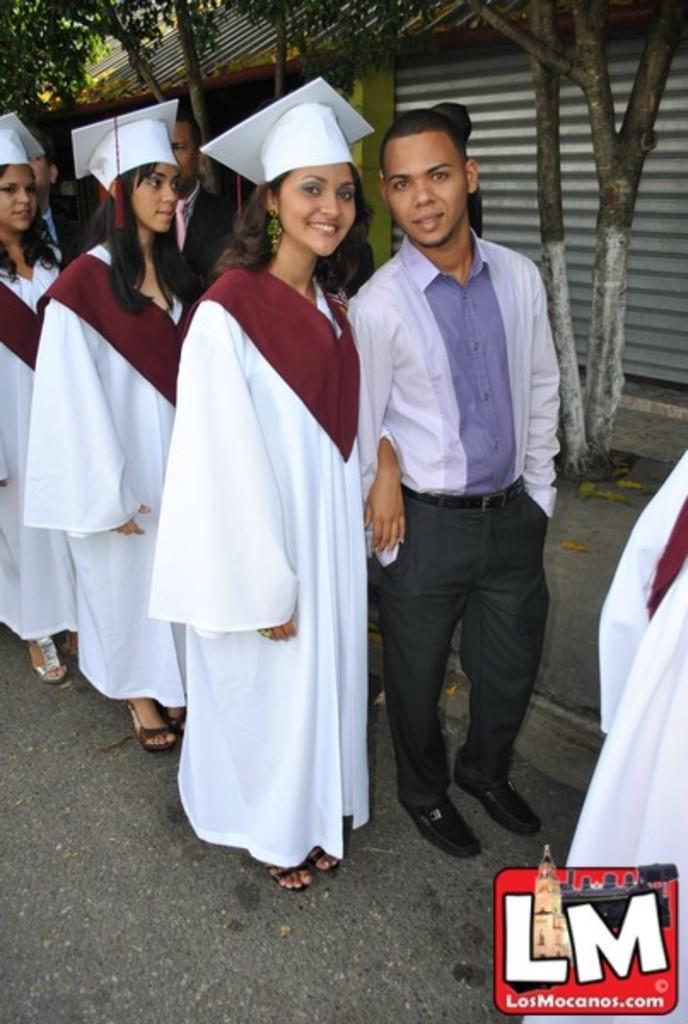Can you describe this image briefly? In the middle a man is standing, he wore white color shirt and trouser. Beside him a beautiful girl is standing and smiling, she wore white color dress, cap. Behind her few other persons are standing on the road, on the right side there is an shed and there are green trees in this image. 